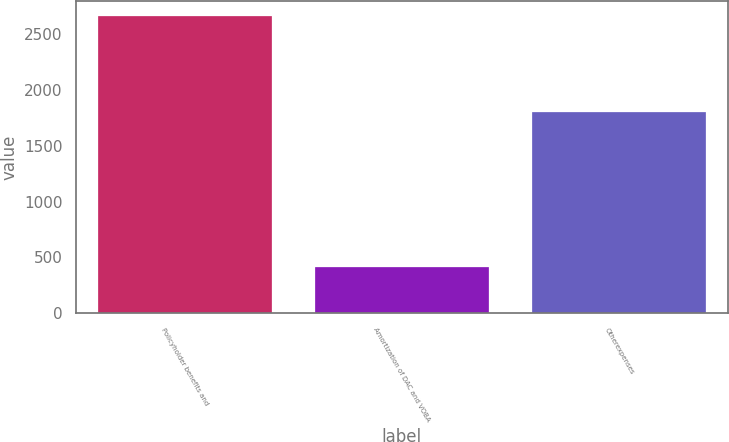<chart> <loc_0><loc_0><loc_500><loc_500><bar_chart><fcel>Policyholder benefits and<fcel>Amortization of DAC and VOBA<fcel>Otherexpenses<nl><fcel>2660<fcel>415<fcel>1797<nl></chart> 